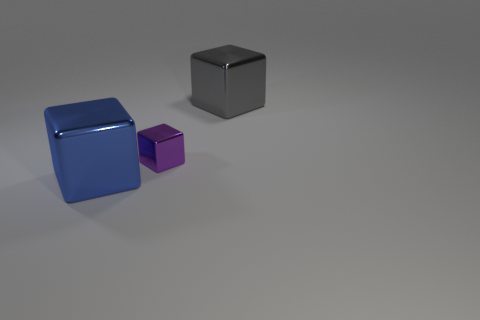How many large metal objects are the same color as the tiny shiny block?
Offer a very short reply. 0. How many things are the same material as the purple block?
Your answer should be compact. 2. What number of objects are either brown matte cylinders or big metal things in front of the large gray metallic cube?
Offer a terse response. 1. There is a large metallic object on the right side of the big cube that is left of the large cube behind the large blue metallic cube; what color is it?
Your answer should be compact. Gray. What is the size of the metallic thing that is to the left of the tiny purple metal object?
Your response must be concise. Large. What number of large objects are metal things or gray blocks?
Provide a short and direct response. 2. There is a object that is right of the blue object and to the left of the big gray metallic thing; what is its color?
Provide a succinct answer. Purple. Are there any other metallic objects of the same shape as the tiny purple object?
Offer a terse response. Yes. What material is the large blue cube?
Provide a short and direct response. Metal. Are there any large gray metallic objects in front of the tiny cube?
Provide a short and direct response. No. 